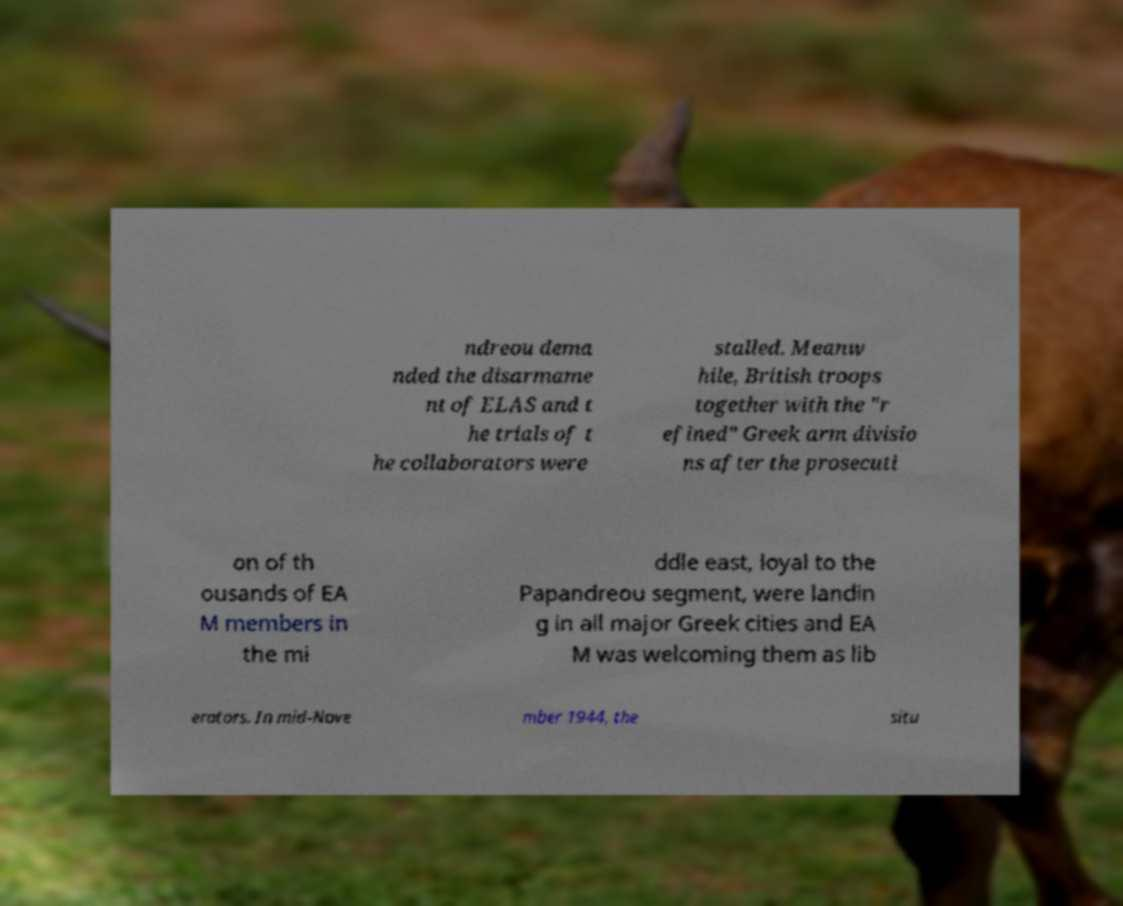Please identify and transcribe the text found in this image. ndreou dema nded the disarmame nt of ELAS and t he trials of t he collaborators were stalled. Meanw hile, British troops together with the "r efined" Greek arm divisio ns after the prosecuti on of th ousands of EA M members in the mi ddle east, loyal to the Papandreou segment, were landin g in all major Greek cities and EA M was welcoming them as lib erators. In mid-Nove mber 1944, the situ 